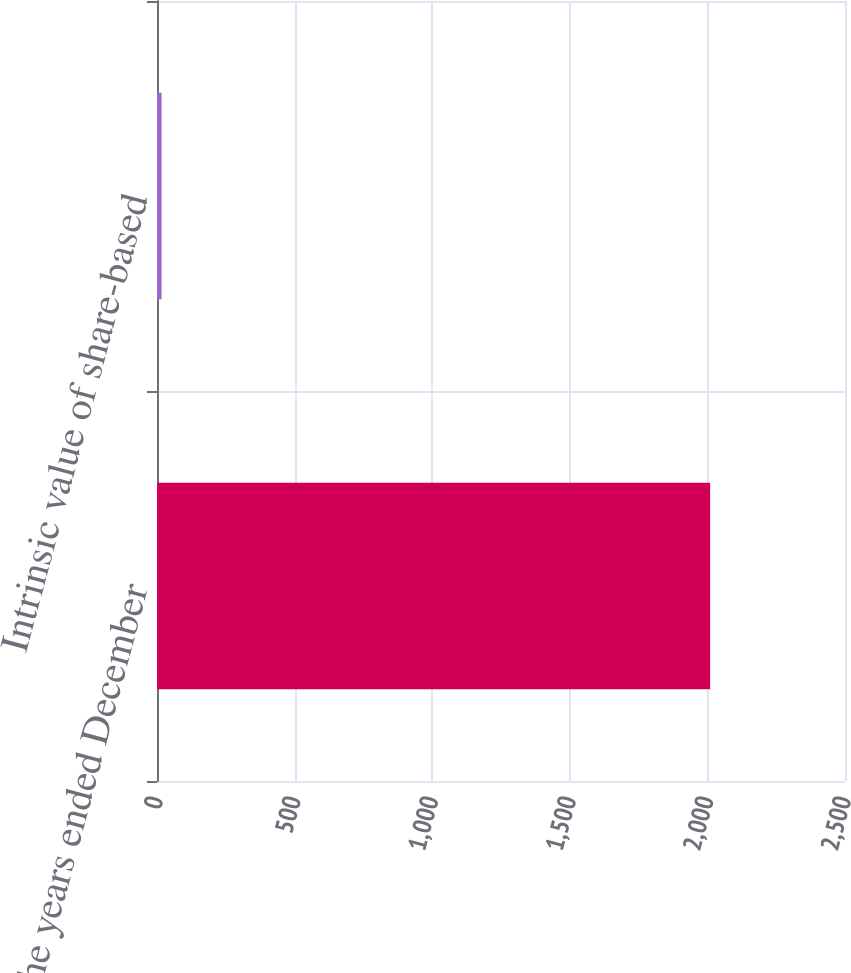Convert chart. <chart><loc_0><loc_0><loc_500><loc_500><bar_chart><fcel>For the years ended December<fcel>Intrinsic value of share-based<nl><fcel>2010<fcel>16.5<nl></chart> 